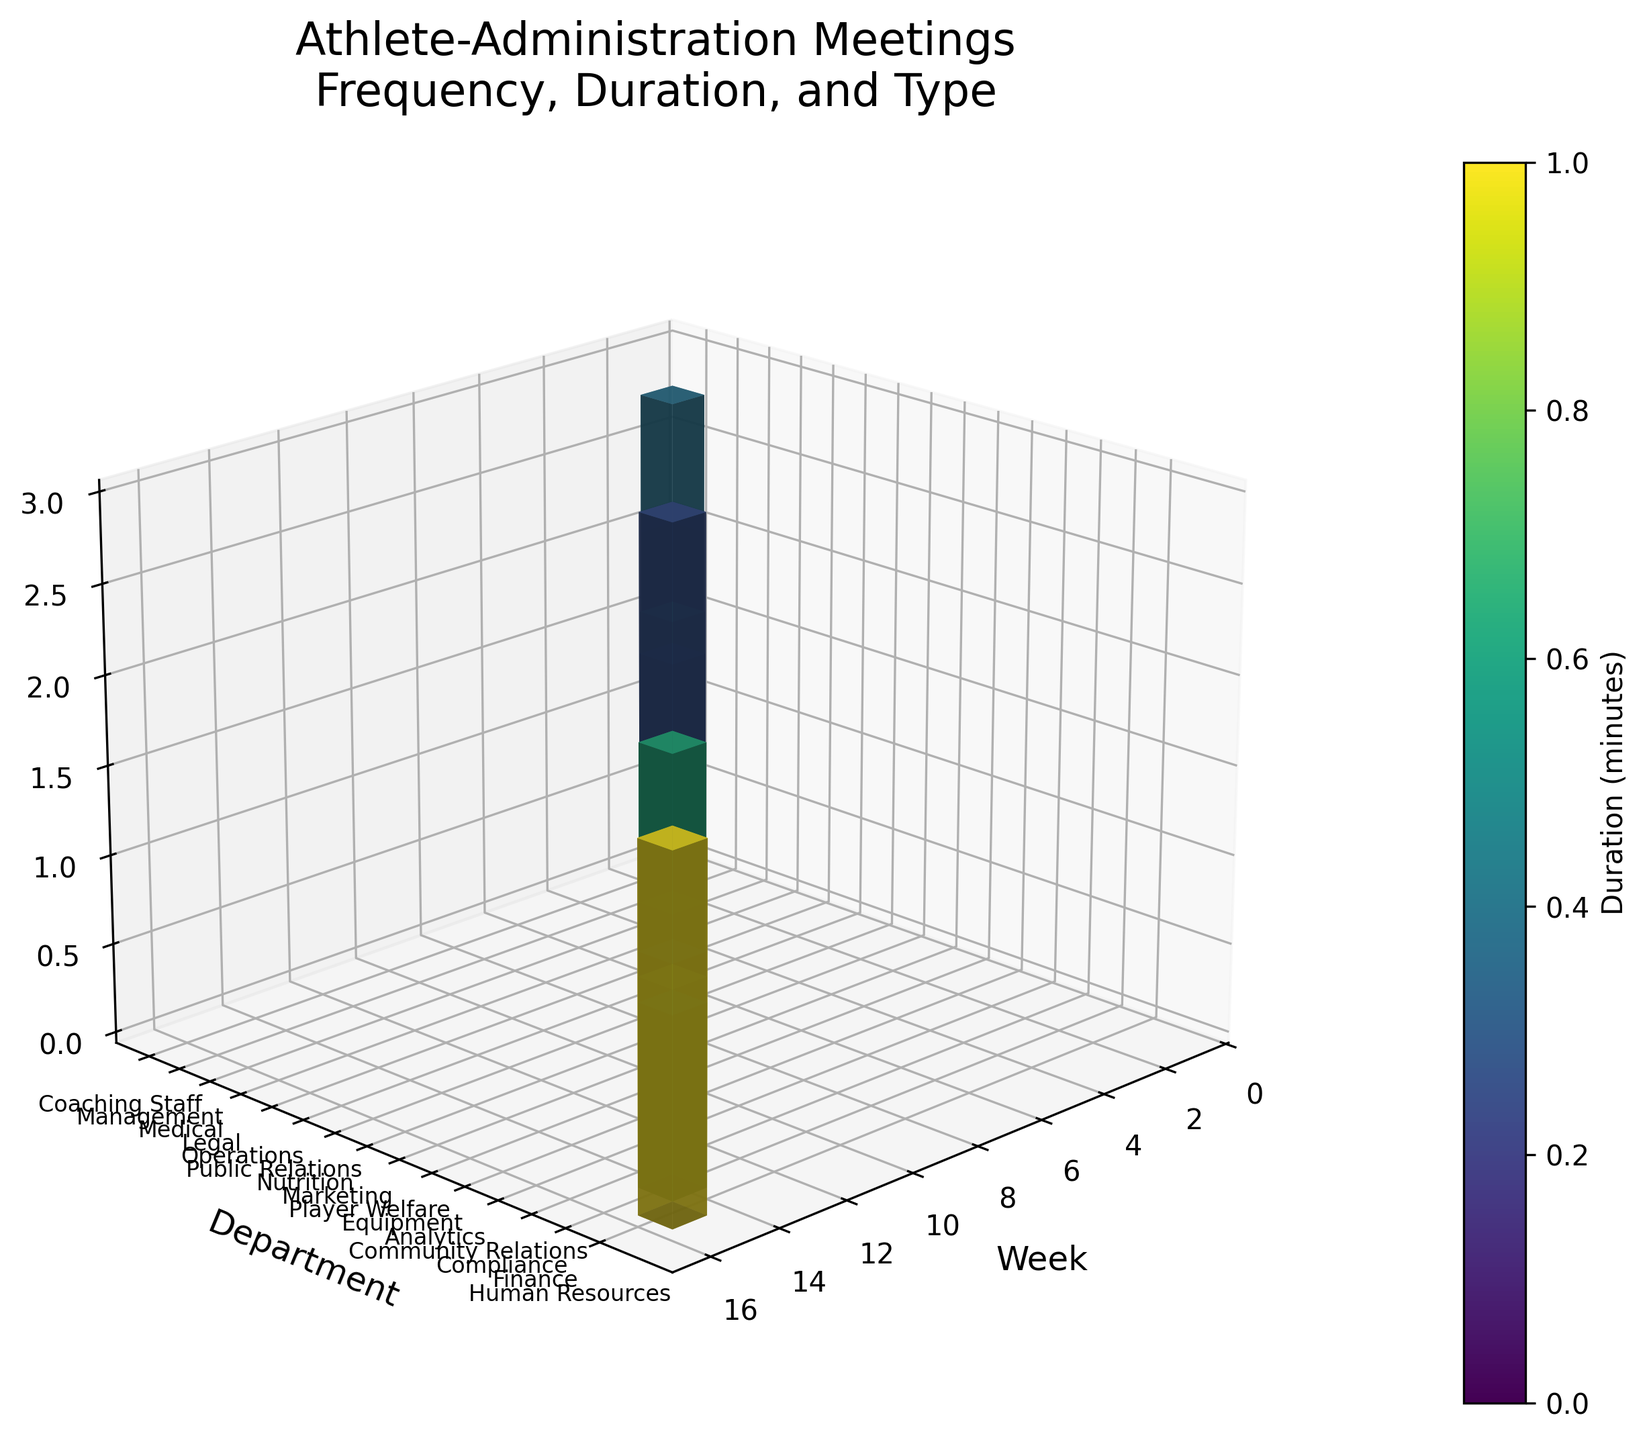What is the title of the figure? The title is generally located at the top of the figure in larger font. It provides a summary of the figure content in one sentence.
Answer: Athlete-Administration Meetings\nFrequency, Duration, and Type Which department has the highest frequency of meetings? To find this, look at the tallest stem in the z-axis dimension and note its corresponding department label on the y-axis.
Answer: Medical Which week had the longest meeting duration? The longest meeting duration can be determined by finding the stem with the darkest color, and then noting its corresponding week on the x-axis.
Answer: Week 4 Which department had meetings with a duration of 75 minutes, and how frequently did these meetings occur? Find the bars with a color corresponding to the color bar value of 75 minutes, and then note their y-axis department labels and z-axis frequency values.
Answer: Operations, Finance; Frequency: 2, 1 What is the average frequency of meetings for departments that had more than one meeting? Identify the departments with more than one meeting frequency on the z-axis, sum their frequencies, and divide by the number of such departments. For Medical (3), Operations (2), Nutrition (2), Analytics (2), and HR (2), (3+2+2+2+2)/5 = 2.2
Answer: 2.2 Compare the frequency and duration of meetings for 'Team Strategy' and 'Contract Negotiation'. Which one is higher in terms of duration and frequency? Look at the department's position on the y-axis, compare the heights (frequency) and colors (duration) of the corresponding stems. 'Team Strategy' has a frequency of 1 and duration of 90 minutes, 'Contract Negotiation' has a frequency of 1 and duration of 120 minutes, so 'Contract Negotiation' has a higher duration but both have the same frequency.
Answer: Contract Negotiation has higher duration; both have same frequency Which department's meetings are the shortest in duration, and how frequently do they occur? The shortest meetings can be determined by finding the stem with the lightest color, and then noting its corresponding department label and frequency.
Answer: Player Welfare, Frequency: 3 